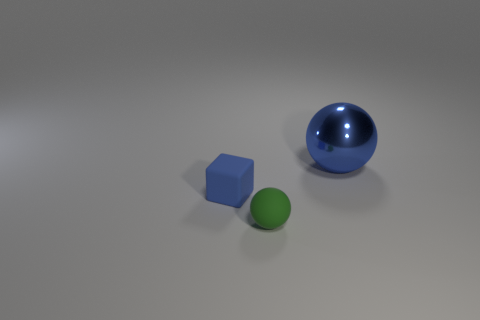Add 1 small green matte balls. How many objects exist? 4 Subtract all cubes. How many objects are left? 2 Add 3 gray matte spheres. How many gray matte spheres exist? 3 Subtract 0 blue cylinders. How many objects are left? 3 Subtract all tiny blue blocks. Subtract all small things. How many objects are left? 0 Add 1 small green rubber objects. How many small green rubber objects are left? 2 